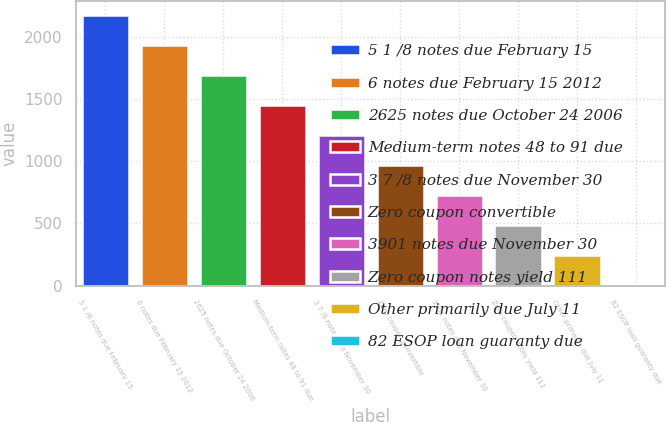<chart> <loc_0><loc_0><loc_500><loc_500><bar_chart><fcel>5 1 /8 notes due February 15<fcel>6 notes due February 15 2012<fcel>2625 notes due October 24 2006<fcel>Medium-term notes 48 to 91 due<fcel>3 7 /8 notes due November 30<fcel>Zero coupon convertible<fcel>3901 notes due November 30<fcel>Zero coupon notes yield 111<fcel>Other primarily due July 11<fcel>82 ESOP loan guaranty due<nl><fcel>2173.9<fcel>1932.8<fcel>1691.7<fcel>1450.6<fcel>1209.5<fcel>968.4<fcel>727.3<fcel>486.2<fcel>245.1<fcel>4<nl></chart> 